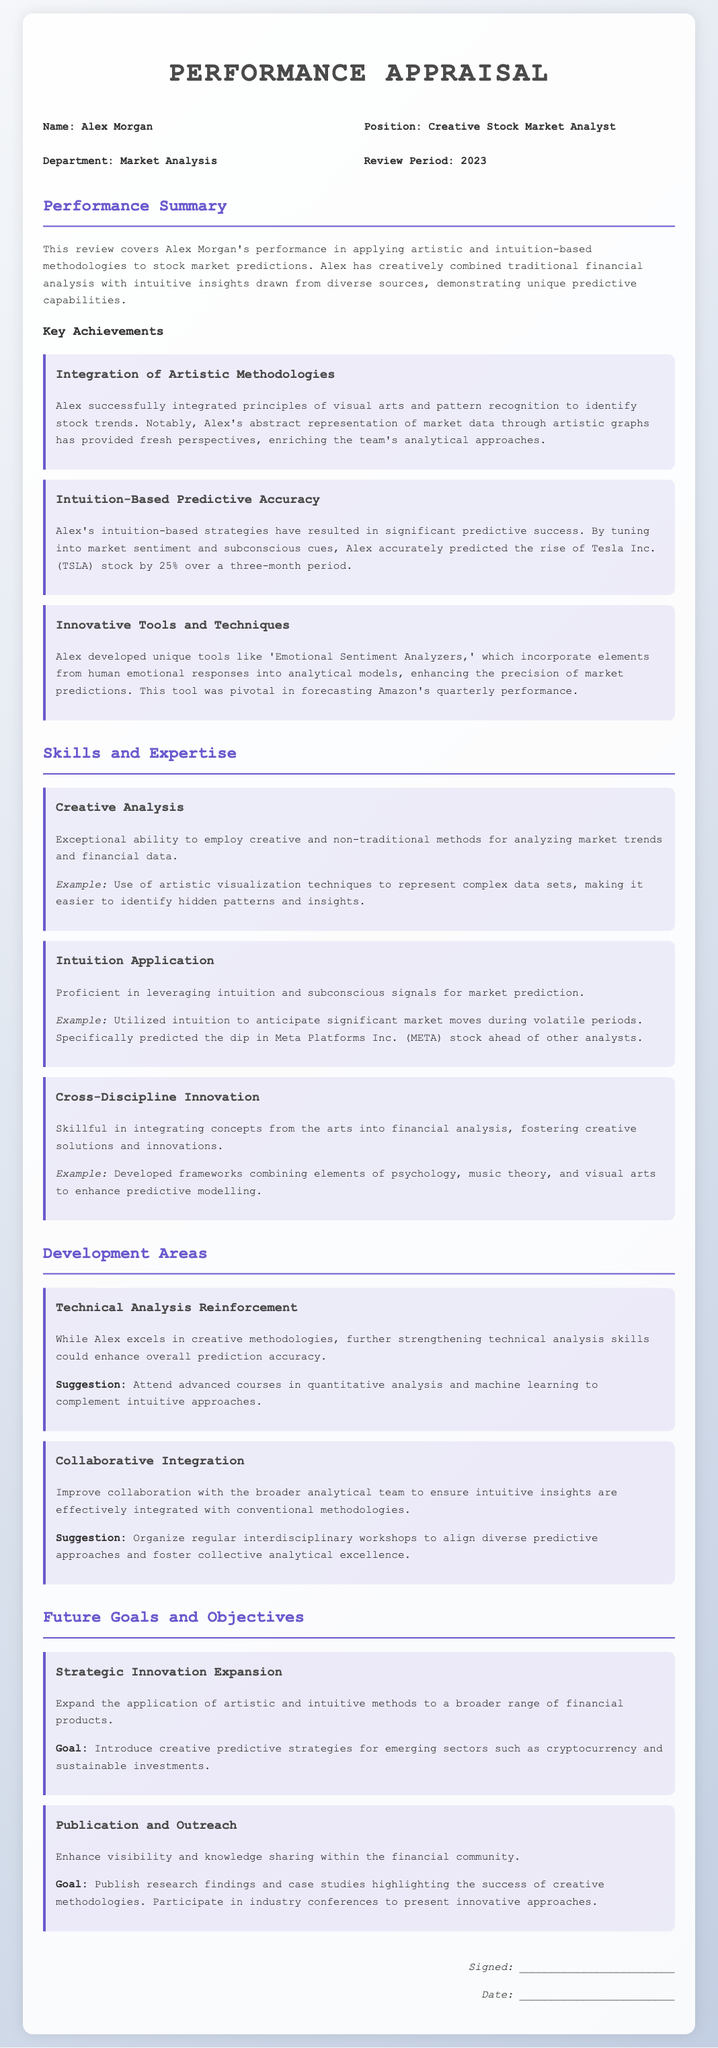What is the name of the individual being appraised? The name of the individual is mentioned under "personal info" and is Alex Morgan.
Answer: Alex Morgan What is the position held by Alex Morgan? The position is listed in the personal information section of the document.
Answer: Creative Stock Market Analyst What year does the review period cover? The review period is specified in the personal information section.
Answer: 2023 What percentage did Alex predict Tesla's stock would rise? The percentage is explicitly stated in the achievements section about predicting Tesla's stock.
Answer: 25% What innovative tool did Alex develop? The tool is mentioned in the achievements section, describing its function in market predictions.
Answer: Emotional Sentiment Analyzers What area does Alex need to reinforce according to the development areas? The development area needing reinforcement is specified clearly in that section.
Answer: Technical Analysis What is one suggested improvement for collaboration? The suggestion is outlined in the development areas for enhancing collaboration.
Answer: Organize regular interdisciplinary workshops What is the goal regarding strategic innovation expansion? The goal is mentioned in the future goals section and describes the broadening application of methods.
Answer: Introduce creative predictive strategies for emerging sectors What is one goal related to publication and outreach? The goal regarding publication is stated in the future goals section focusing on knowledge sharing.
Answer: Publish research findings and case studies 